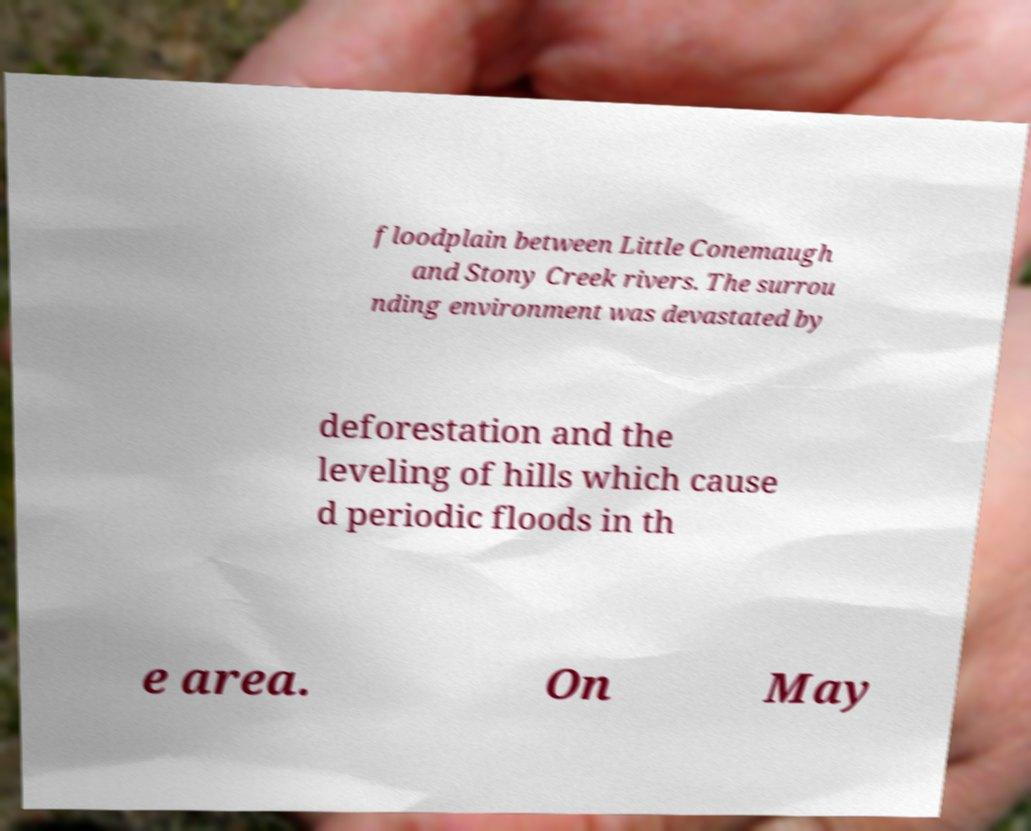Could you extract and type out the text from this image? floodplain between Little Conemaugh and Stony Creek rivers. The surrou nding environment was devastated by deforestation and the leveling of hills which cause d periodic floods in th e area. On May 